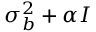<formula> <loc_0><loc_0><loc_500><loc_500>\sigma _ { b } ^ { 2 } + \alpha I</formula> 